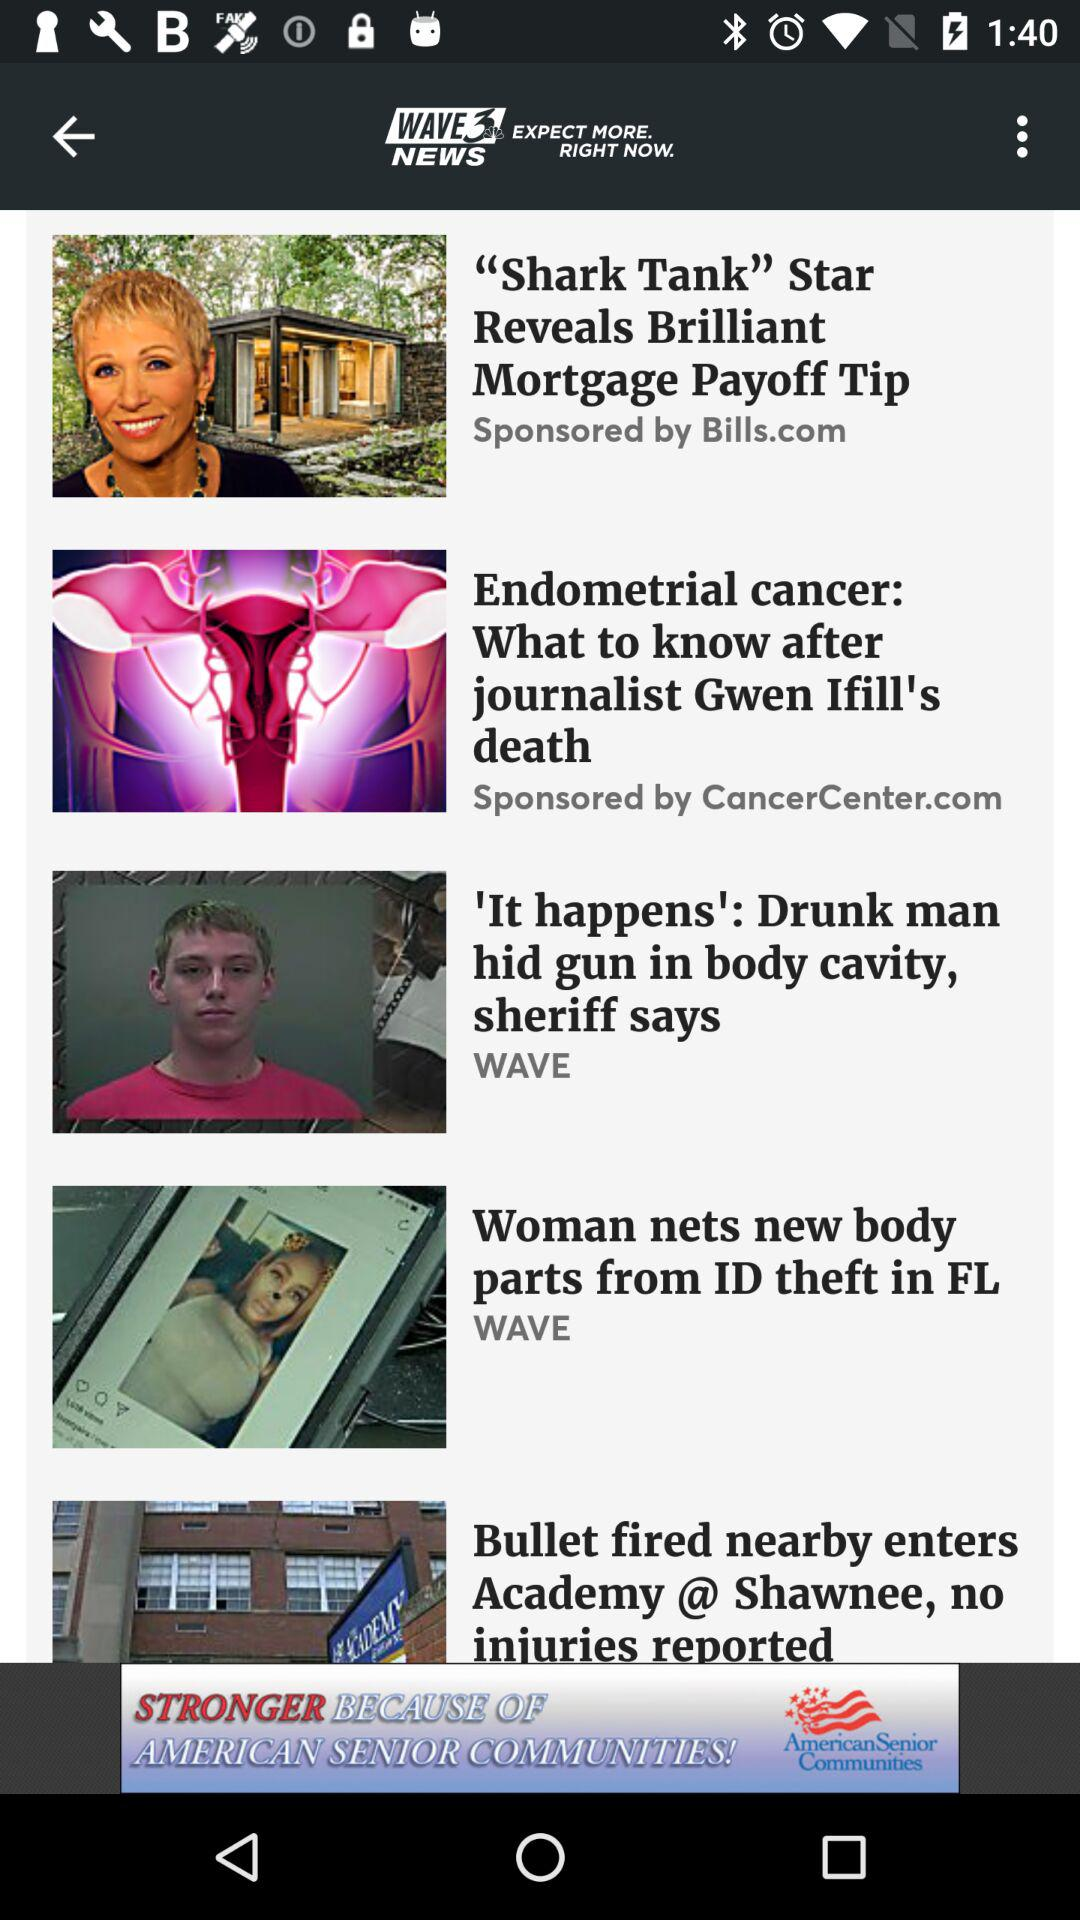Who sponsored "Endometrial cancer: What to know after journalist Gwen Ifill's death"? It was sponsored by CancerCenter.com. 